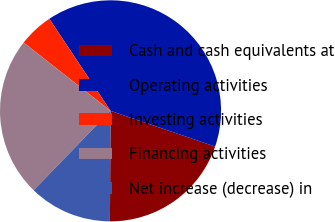Convert chart to OTSL. <chart><loc_0><loc_0><loc_500><loc_500><pie_chart><fcel>Cash and cash equivalents at<fcel>Operating activities<fcel>Investing activities<fcel>Financing activities<fcel>Net increase (decrease) in<nl><fcel>19.85%<fcel>39.58%<fcel>5.06%<fcel>23.36%<fcel>12.15%<nl></chart> 